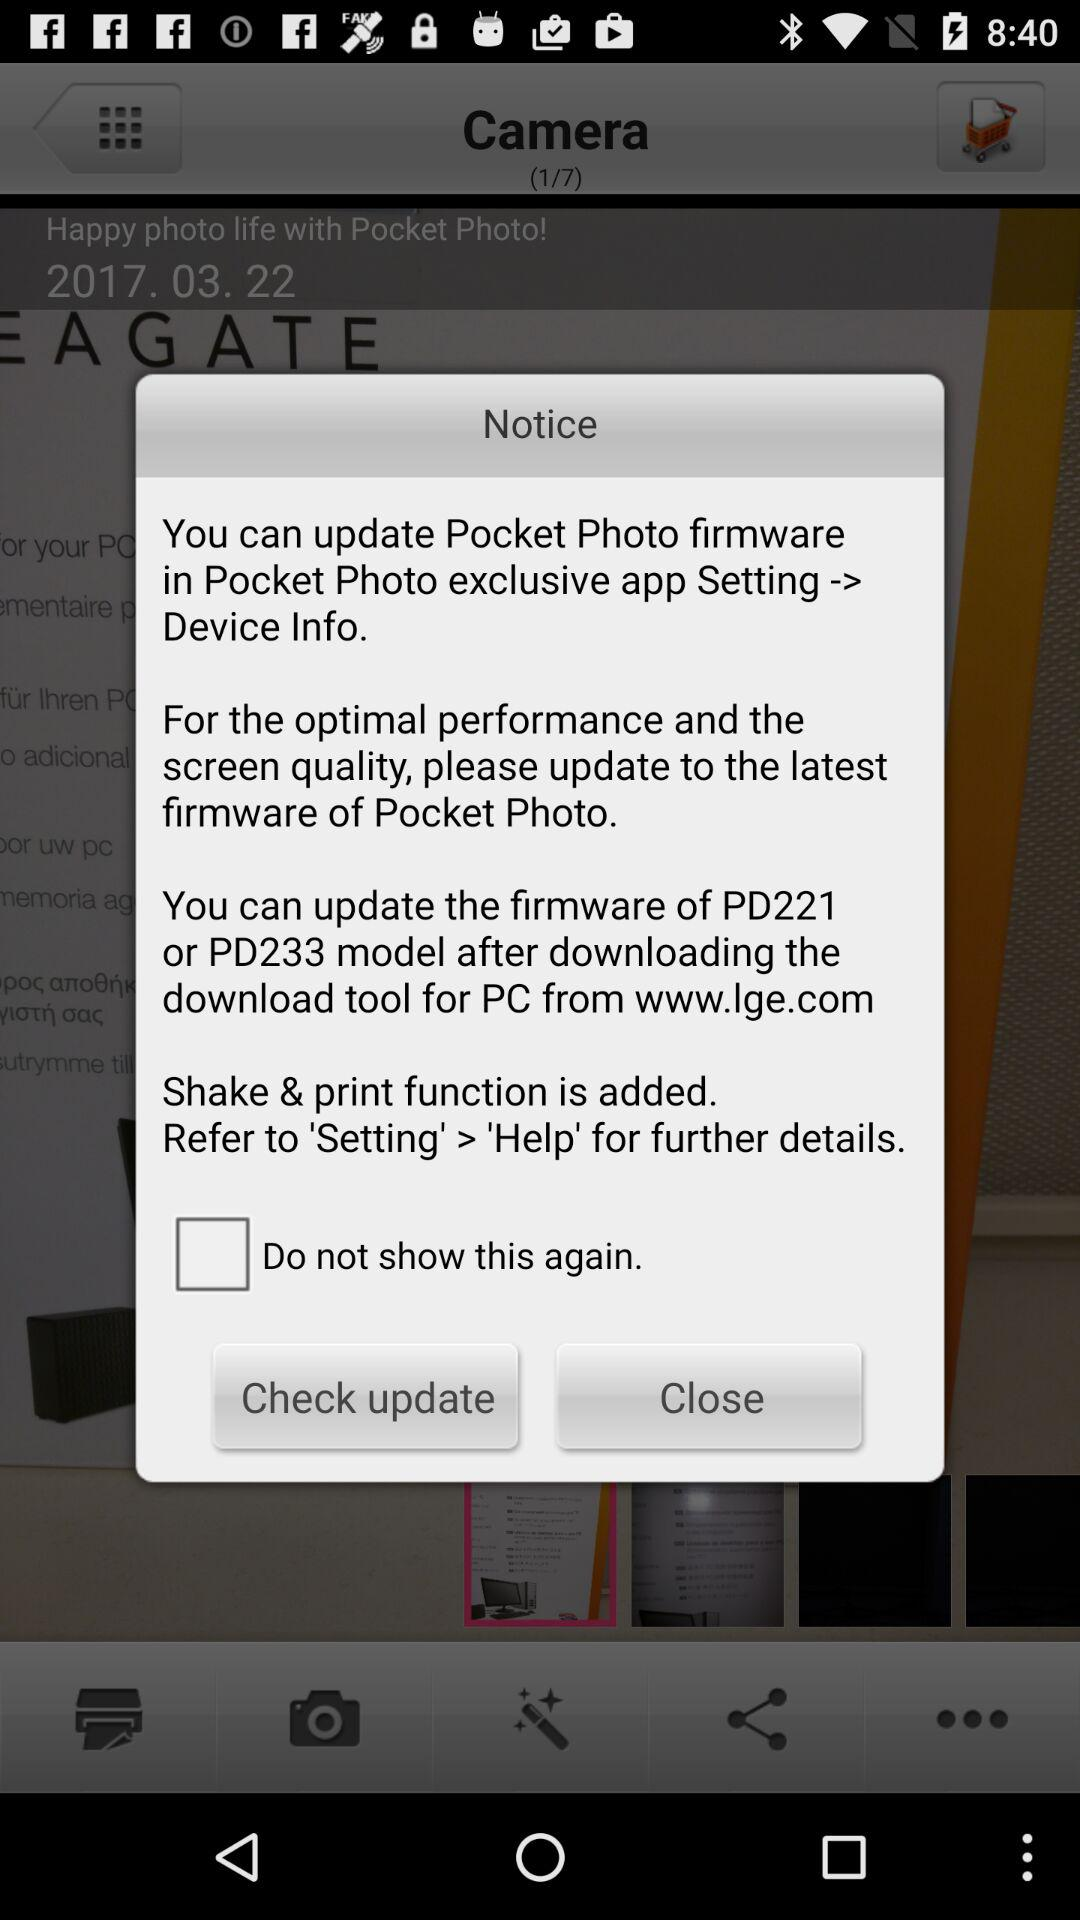How many firmware versions are mentioned in the notice?
Answer the question using a single word or phrase. 2 